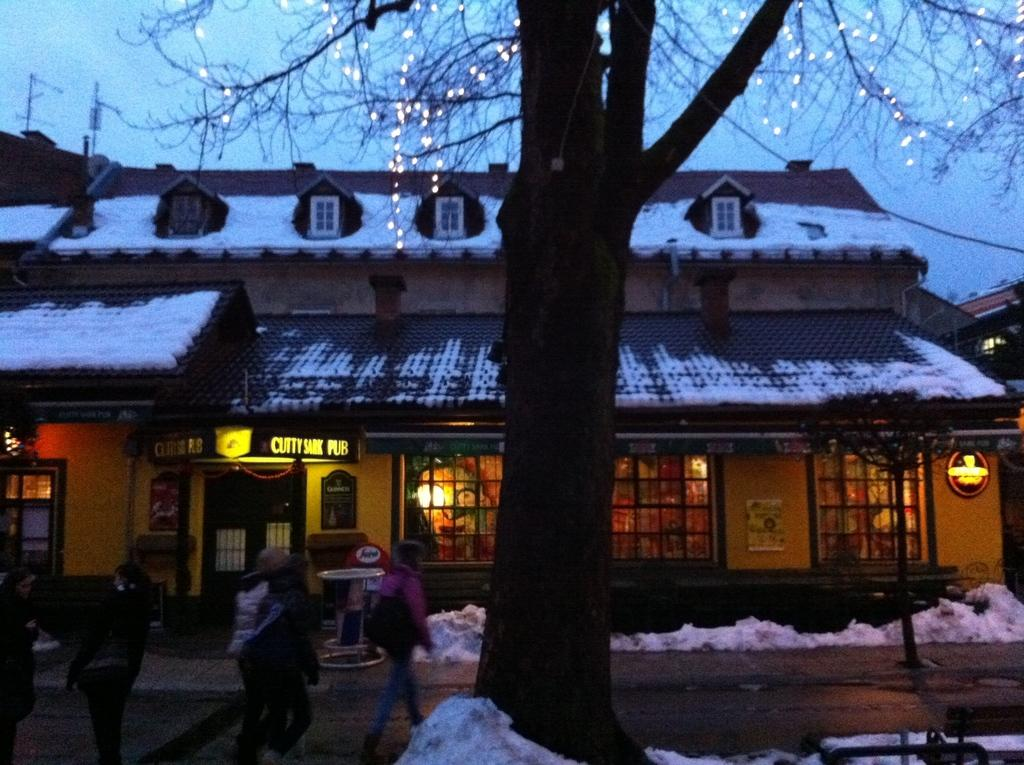What is the main subject in the middle of the image? There is a house in the middle of the image. What is the condition of the ice in the image? The ice is present in the image, but its condition is not specified. Who or what can be seen at the bottom of the image? There are people at the bottom of the image. What other natural element is present in the image? There is a tree in the middle of the image. What is visible at the top of the image? The sky is visible at the top of the image. What payment method is accepted at the house in the image? There is no information about payment methods in the image, as it only shows a house, ice, people, a tree, and the sky. 